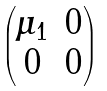Convert formula to latex. <formula><loc_0><loc_0><loc_500><loc_500>\begin{pmatrix} \mu _ { 1 } & 0 \\ 0 & 0 \end{pmatrix}</formula> 